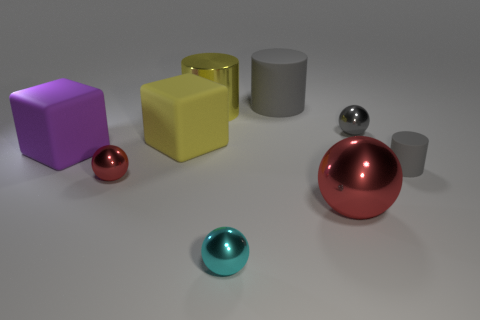There is a gray cylinder behind the metal cylinder; is it the same size as the yellow matte block?
Your response must be concise. Yes. What is the size of the cyan object?
Offer a terse response. Small. Is there a thing of the same color as the large matte cylinder?
Make the answer very short. Yes. What number of tiny things are either cubes or shiny objects?
Offer a terse response. 3. There is a shiny object that is on the right side of the tiny cyan shiny object and in front of the small gray matte cylinder; what size is it?
Ensure brevity in your answer.  Large. What number of large gray matte cylinders are in front of the big purple matte block?
Your answer should be very brief. 0. The small metal thing that is behind the large red metallic ball and in front of the purple matte block has what shape?
Make the answer very short. Sphere. What material is the other tiny thing that is the same color as the small rubber thing?
Offer a terse response. Metal. What number of cylinders are either big gray rubber objects or tiny cyan things?
Keep it short and to the point. 1. What is the size of the sphere that is the same color as the big matte cylinder?
Your response must be concise. Small. 